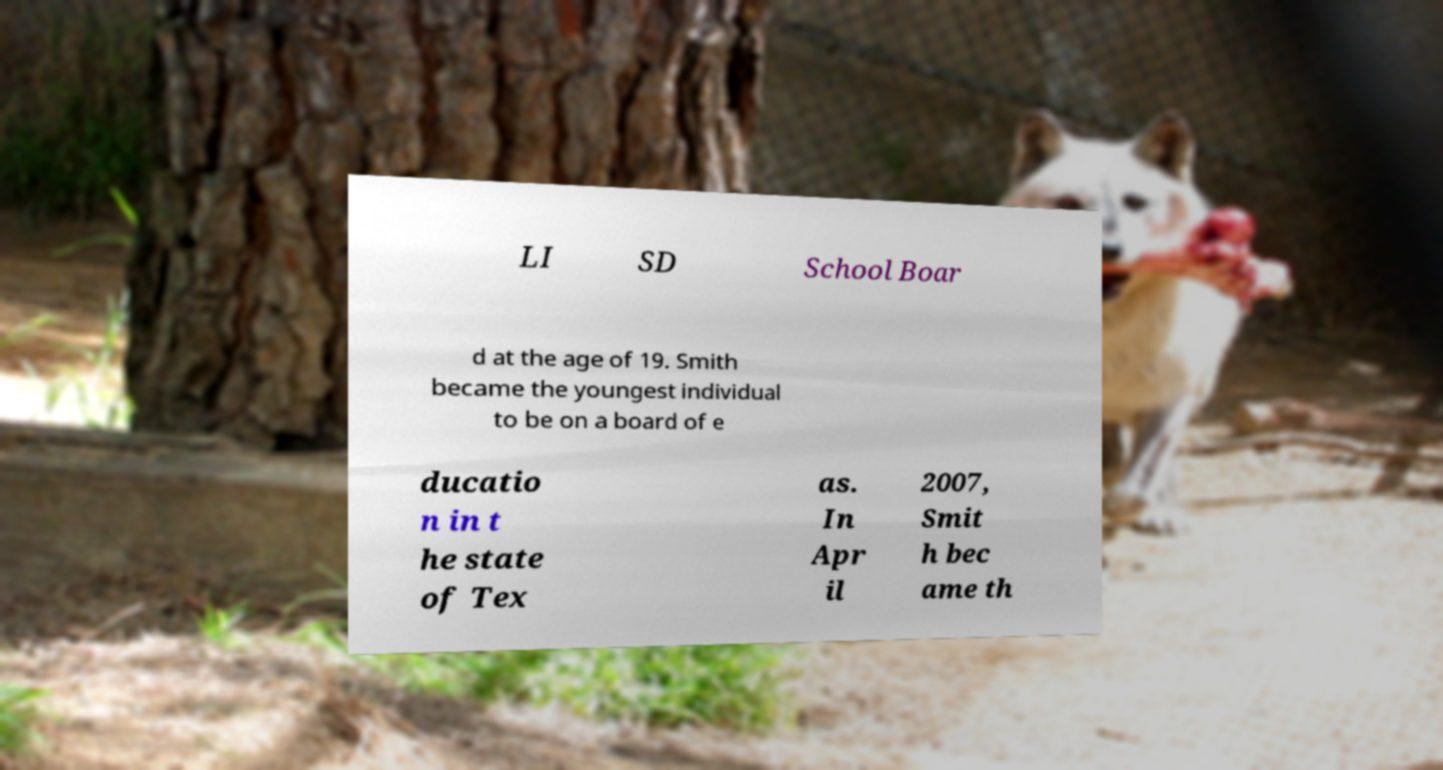Please read and relay the text visible in this image. What does it say? LI SD School Boar d at the age of 19. Smith became the youngest individual to be on a board of e ducatio n in t he state of Tex as. In Apr il 2007, Smit h bec ame th 